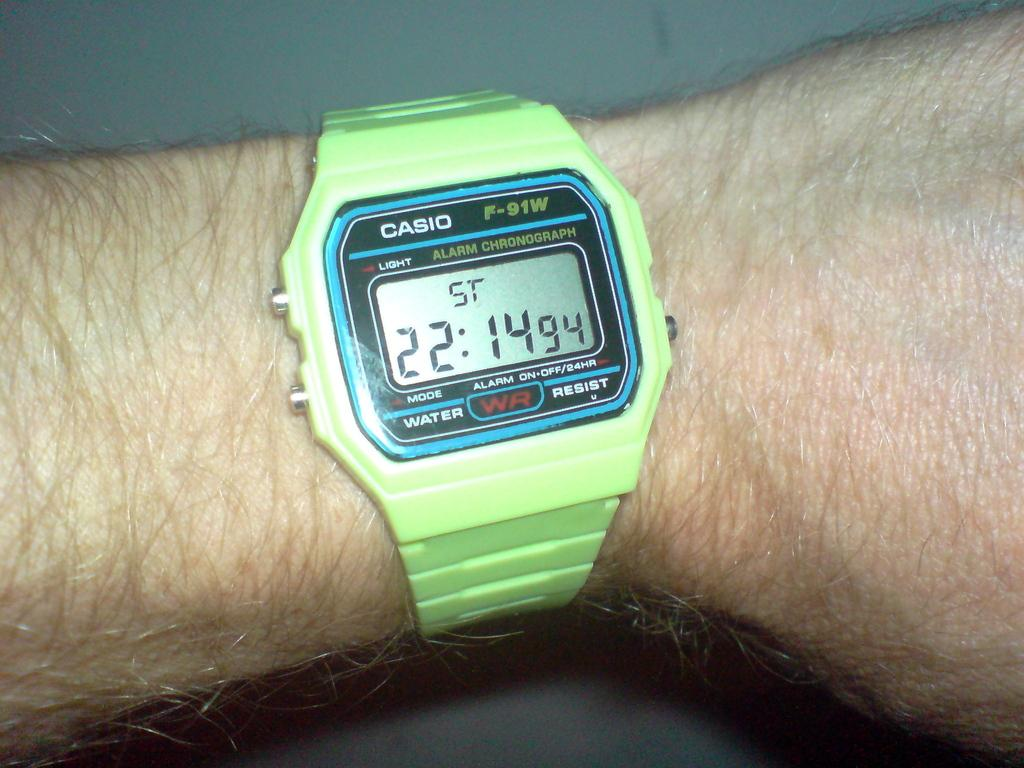<image>
Write a terse but informative summary of the picture. A wrist wearing a green Casio watch the time reads 22:14 